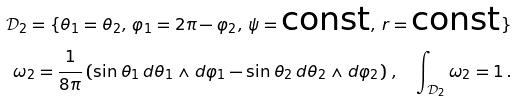<formula> <loc_0><loc_0><loc_500><loc_500>\mathcal { D } _ { 2 } = \{ \theta _ { 1 } = \theta _ { 2 } , \, \varphi _ { 1 } = 2 \pi - \varphi _ { 2 } , \, \psi = \text {const} , \, r = \text {const} \} \\ \omega _ { 2 } = \frac { 1 } { 8 \pi } \left ( \sin \theta _ { 1 } \, d \theta _ { 1 } \wedge d \varphi _ { 1 } - \sin \theta _ { 2 } \, d \theta _ { 2 } \wedge d \varphi _ { 2 } \right ) \, , \quad \int _ { \mathcal { D } _ { 2 } } \omega _ { 2 } = 1 \, .</formula> 